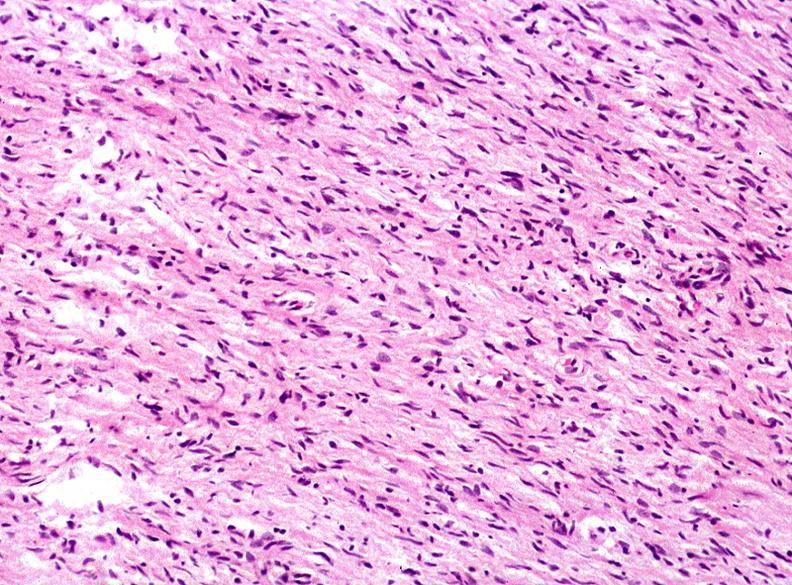does this image show skin, neurofibromatosis?
Answer the question using a single word or phrase. Yes 